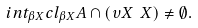<formula> <loc_0><loc_0><loc_500><loc_500>i n t _ { \beta X } c l _ { \beta X } A \cap ( \upsilon X \ X ) \neq \emptyset .</formula> 